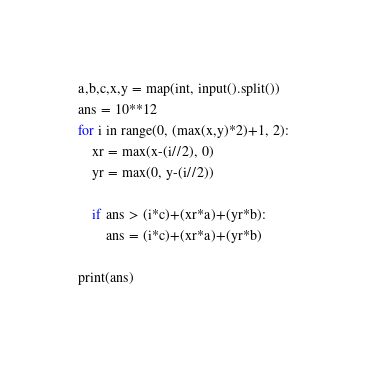<code> <loc_0><loc_0><loc_500><loc_500><_Python_>a,b,c,x,y = map(int, input().split())
ans = 10**12
for i in range(0, (max(x,y)*2)+1, 2):
    xr = max(x-(i//2), 0)
    yr = max(0, y-(i//2))

    if ans > (i*c)+(xr*a)+(yr*b):
        ans = (i*c)+(xr*a)+(yr*b)

print(ans)</code> 